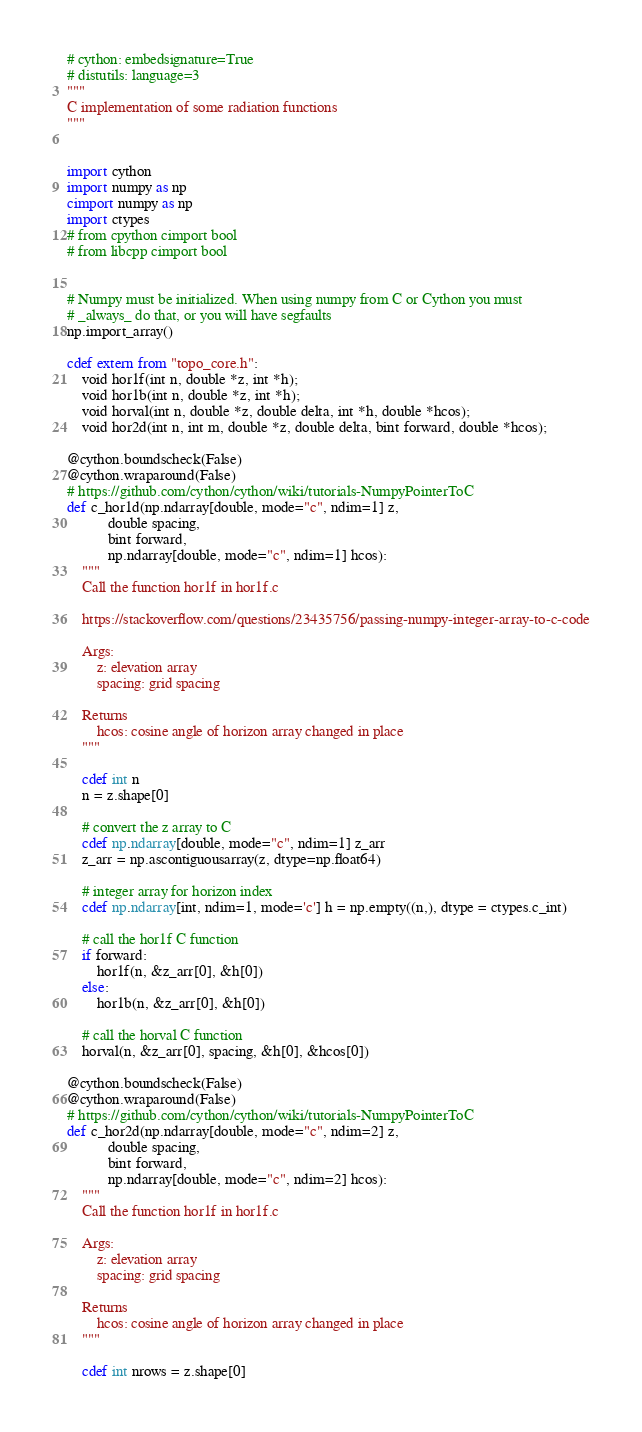<code> <loc_0><loc_0><loc_500><loc_500><_Cython_># cython: embedsignature=True
# distutils: language=3
"""
C implementation of some radiation functions
"""


import cython
import numpy as np
cimport numpy as np
import ctypes
# from cpython cimport bool
# from libcpp cimport bool


# Numpy must be initialized. When using numpy from C or Cython you must
# _always_ do that, or you will have segfaults
np.import_array()

cdef extern from "topo_core.h":
    void hor1f(int n, double *z, int *h);
    void hor1b(int n, double *z, int *h);
    void horval(int n, double *z, double delta, int *h, double *hcos);
    void hor2d(int n, int m, double *z, double delta, bint forward, double *hcos);

@cython.boundscheck(False)
@cython.wraparound(False)
# https://github.com/cython/cython/wiki/tutorials-NumpyPointerToC
def c_hor1d(np.ndarray[double, mode="c", ndim=1] z,
           double spacing,
           bint forward,
           np.ndarray[double, mode="c", ndim=1] hcos):
    """
    Call the function hor1f in hor1f.c

    https://stackoverflow.com/questions/23435756/passing-numpy-integer-array-to-c-code

    Args:
        z: elevation array
        spacing: grid spacing
    
    Returns
        hcos: cosine angle of horizon array changed in place
    """

    cdef int n
    n = z.shape[0]

    # convert the z array to C
    cdef np.ndarray[double, mode="c", ndim=1] z_arr
    z_arr = np.ascontiguousarray(z, dtype=np.float64)

    # integer array for horizon index
    cdef np.ndarray[int, ndim=1, mode='c'] h = np.empty((n,), dtype = ctypes.c_int)

    # call the hor1f C function
    if forward:
        hor1f(n, &z_arr[0], &h[0])
    else:
        hor1b(n, &z_arr[0], &h[0])
    
    # call the horval C function
    horval(n, &z_arr[0], spacing, &h[0], &hcos[0])

@cython.boundscheck(False)
@cython.wraparound(False)
# https://github.com/cython/cython/wiki/tutorials-NumpyPointerToC
def c_hor2d(np.ndarray[double, mode="c", ndim=2] z,
           double spacing,
           bint forward,
           np.ndarray[double, mode="c", ndim=2] hcos):
    """
    Call the function hor1f in hor1f.c

    Args:
        z: elevation array
        spacing: grid spacing
    
    Returns
        hcos: cosine angle of horizon array changed in place
    """

    cdef int nrows = z.shape[0]</code> 